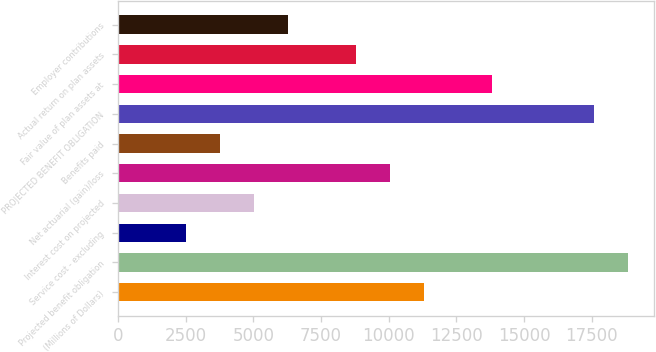Convert chart. <chart><loc_0><loc_0><loc_500><loc_500><bar_chart><fcel>(Millions of Dollars)<fcel>Projected benefit obligation<fcel>Service cost - excluding<fcel>Interest cost on projected<fcel>Net actuarial (gain)/loss<fcel>Benefits paid<fcel>PROJECTED BENEFIT OBLIGATION<fcel>Fair value of plan assets at<fcel>Actual return on plan assets<fcel>Employer contributions<nl><fcel>11315.4<fcel>18855<fcel>2519.2<fcel>5032.4<fcel>10058.8<fcel>3775.8<fcel>17598.4<fcel>13828.6<fcel>8802.2<fcel>6289<nl></chart> 